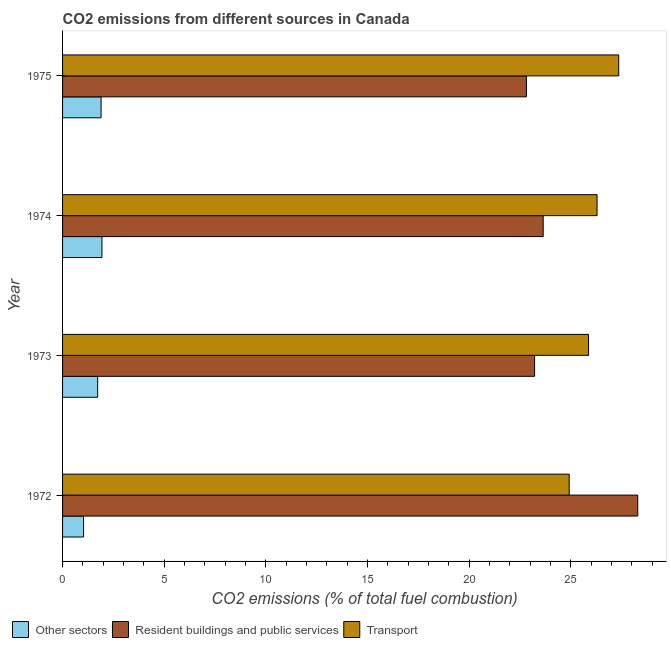How many different coloured bars are there?
Offer a very short reply. 3. Are the number of bars on each tick of the Y-axis equal?
Give a very brief answer. Yes. How many bars are there on the 3rd tick from the top?
Your response must be concise. 3. How many bars are there on the 1st tick from the bottom?
Keep it short and to the point. 3. In how many cases, is the number of bars for a given year not equal to the number of legend labels?
Offer a terse response. 0. What is the percentage of co2 emissions from transport in 1973?
Your answer should be very brief. 25.87. Across all years, what is the maximum percentage of co2 emissions from other sectors?
Your answer should be compact. 1.94. Across all years, what is the minimum percentage of co2 emissions from other sectors?
Give a very brief answer. 1.03. In which year was the percentage of co2 emissions from other sectors maximum?
Make the answer very short. 1974. In which year was the percentage of co2 emissions from resident buildings and public services minimum?
Provide a short and direct response. 1975. What is the total percentage of co2 emissions from transport in the graph?
Make the answer very short. 104.45. What is the difference between the percentage of co2 emissions from transport in 1973 and that in 1974?
Provide a short and direct response. -0.42. What is the difference between the percentage of co2 emissions from transport in 1974 and the percentage of co2 emissions from resident buildings and public services in 1972?
Offer a very short reply. -2. What is the average percentage of co2 emissions from other sectors per year?
Your answer should be compact. 1.65. In the year 1974, what is the difference between the percentage of co2 emissions from transport and percentage of co2 emissions from resident buildings and public services?
Make the answer very short. 2.65. In how many years, is the percentage of co2 emissions from other sectors greater than 20 %?
Keep it short and to the point. 0. What is the ratio of the percentage of co2 emissions from other sectors in 1972 to that in 1973?
Offer a very short reply. 0.6. Is the percentage of co2 emissions from resident buildings and public services in 1973 less than that in 1975?
Ensure brevity in your answer.  No. Is the difference between the percentage of co2 emissions from resident buildings and public services in 1973 and 1974 greater than the difference between the percentage of co2 emissions from other sectors in 1973 and 1974?
Make the answer very short. No. What is the difference between the highest and the second highest percentage of co2 emissions from other sectors?
Provide a succinct answer. 0.04. What is the difference between the highest and the lowest percentage of co2 emissions from transport?
Provide a short and direct response. 2.44. In how many years, is the percentage of co2 emissions from resident buildings and public services greater than the average percentage of co2 emissions from resident buildings and public services taken over all years?
Offer a terse response. 1. What does the 1st bar from the top in 1972 represents?
Your response must be concise. Transport. What does the 1st bar from the bottom in 1972 represents?
Provide a short and direct response. Other sectors. Is it the case that in every year, the sum of the percentage of co2 emissions from other sectors and percentage of co2 emissions from resident buildings and public services is greater than the percentage of co2 emissions from transport?
Your response must be concise. No. How many bars are there?
Your response must be concise. 12. Are all the bars in the graph horizontal?
Give a very brief answer. Yes. How many years are there in the graph?
Make the answer very short. 4. Does the graph contain any zero values?
Your response must be concise. No. Where does the legend appear in the graph?
Offer a terse response. Bottom left. How are the legend labels stacked?
Your response must be concise. Horizontal. What is the title of the graph?
Offer a terse response. CO2 emissions from different sources in Canada. What is the label or title of the X-axis?
Keep it short and to the point. CO2 emissions (% of total fuel combustion). What is the CO2 emissions (% of total fuel combustion) of Other sectors in 1972?
Provide a short and direct response. 1.03. What is the CO2 emissions (% of total fuel combustion) of Resident buildings and public services in 1972?
Your answer should be compact. 28.29. What is the CO2 emissions (% of total fuel combustion) in Transport in 1972?
Your response must be concise. 24.92. What is the CO2 emissions (% of total fuel combustion) in Other sectors in 1973?
Offer a terse response. 1.73. What is the CO2 emissions (% of total fuel combustion) in Resident buildings and public services in 1973?
Provide a short and direct response. 23.22. What is the CO2 emissions (% of total fuel combustion) of Transport in 1973?
Your answer should be compact. 25.87. What is the CO2 emissions (% of total fuel combustion) in Other sectors in 1974?
Make the answer very short. 1.94. What is the CO2 emissions (% of total fuel combustion) of Resident buildings and public services in 1974?
Your answer should be compact. 23.64. What is the CO2 emissions (% of total fuel combustion) in Transport in 1974?
Provide a succinct answer. 26.29. What is the CO2 emissions (% of total fuel combustion) of Other sectors in 1975?
Make the answer very short. 1.89. What is the CO2 emissions (% of total fuel combustion) in Resident buildings and public services in 1975?
Your answer should be compact. 22.82. What is the CO2 emissions (% of total fuel combustion) in Transport in 1975?
Provide a short and direct response. 27.36. Across all years, what is the maximum CO2 emissions (% of total fuel combustion) of Other sectors?
Your answer should be compact. 1.94. Across all years, what is the maximum CO2 emissions (% of total fuel combustion) of Resident buildings and public services?
Offer a very short reply. 28.29. Across all years, what is the maximum CO2 emissions (% of total fuel combustion) in Transport?
Provide a succinct answer. 27.36. Across all years, what is the minimum CO2 emissions (% of total fuel combustion) in Other sectors?
Your answer should be compact. 1.03. Across all years, what is the minimum CO2 emissions (% of total fuel combustion) of Resident buildings and public services?
Your answer should be compact. 22.82. Across all years, what is the minimum CO2 emissions (% of total fuel combustion) of Transport?
Offer a very short reply. 24.92. What is the total CO2 emissions (% of total fuel combustion) in Other sectors in the graph?
Provide a succinct answer. 6.59. What is the total CO2 emissions (% of total fuel combustion) in Resident buildings and public services in the graph?
Give a very brief answer. 97.97. What is the total CO2 emissions (% of total fuel combustion) in Transport in the graph?
Make the answer very short. 104.45. What is the difference between the CO2 emissions (% of total fuel combustion) of Other sectors in 1972 and that in 1973?
Offer a very short reply. -0.69. What is the difference between the CO2 emissions (% of total fuel combustion) of Resident buildings and public services in 1972 and that in 1973?
Give a very brief answer. 5.07. What is the difference between the CO2 emissions (% of total fuel combustion) in Transport in 1972 and that in 1973?
Give a very brief answer. -0.95. What is the difference between the CO2 emissions (% of total fuel combustion) of Other sectors in 1972 and that in 1974?
Your answer should be compact. -0.9. What is the difference between the CO2 emissions (% of total fuel combustion) in Resident buildings and public services in 1972 and that in 1974?
Give a very brief answer. 4.65. What is the difference between the CO2 emissions (% of total fuel combustion) in Transport in 1972 and that in 1974?
Offer a terse response. -1.37. What is the difference between the CO2 emissions (% of total fuel combustion) of Other sectors in 1972 and that in 1975?
Keep it short and to the point. -0.86. What is the difference between the CO2 emissions (% of total fuel combustion) of Resident buildings and public services in 1972 and that in 1975?
Give a very brief answer. 5.48. What is the difference between the CO2 emissions (% of total fuel combustion) in Transport in 1972 and that in 1975?
Ensure brevity in your answer.  -2.44. What is the difference between the CO2 emissions (% of total fuel combustion) in Other sectors in 1973 and that in 1974?
Your answer should be compact. -0.21. What is the difference between the CO2 emissions (% of total fuel combustion) of Resident buildings and public services in 1973 and that in 1974?
Offer a very short reply. -0.42. What is the difference between the CO2 emissions (% of total fuel combustion) in Transport in 1973 and that in 1974?
Ensure brevity in your answer.  -0.42. What is the difference between the CO2 emissions (% of total fuel combustion) of Other sectors in 1973 and that in 1975?
Give a very brief answer. -0.17. What is the difference between the CO2 emissions (% of total fuel combustion) of Resident buildings and public services in 1973 and that in 1975?
Ensure brevity in your answer.  0.4. What is the difference between the CO2 emissions (% of total fuel combustion) in Transport in 1973 and that in 1975?
Ensure brevity in your answer.  -1.48. What is the difference between the CO2 emissions (% of total fuel combustion) in Other sectors in 1974 and that in 1975?
Keep it short and to the point. 0.04. What is the difference between the CO2 emissions (% of total fuel combustion) in Resident buildings and public services in 1974 and that in 1975?
Ensure brevity in your answer.  0.82. What is the difference between the CO2 emissions (% of total fuel combustion) in Transport in 1974 and that in 1975?
Offer a terse response. -1.07. What is the difference between the CO2 emissions (% of total fuel combustion) in Other sectors in 1972 and the CO2 emissions (% of total fuel combustion) in Resident buildings and public services in 1973?
Make the answer very short. -22.19. What is the difference between the CO2 emissions (% of total fuel combustion) in Other sectors in 1972 and the CO2 emissions (% of total fuel combustion) in Transport in 1973?
Your answer should be very brief. -24.84. What is the difference between the CO2 emissions (% of total fuel combustion) in Resident buildings and public services in 1972 and the CO2 emissions (% of total fuel combustion) in Transport in 1973?
Your answer should be very brief. 2.42. What is the difference between the CO2 emissions (% of total fuel combustion) of Other sectors in 1972 and the CO2 emissions (% of total fuel combustion) of Resident buildings and public services in 1974?
Your response must be concise. -22.61. What is the difference between the CO2 emissions (% of total fuel combustion) of Other sectors in 1972 and the CO2 emissions (% of total fuel combustion) of Transport in 1974?
Make the answer very short. -25.26. What is the difference between the CO2 emissions (% of total fuel combustion) of Resident buildings and public services in 1972 and the CO2 emissions (% of total fuel combustion) of Transport in 1974?
Keep it short and to the point. 2. What is the difference between the CO2 emissions (% of total fuel combustion) of Other sectors in 1972 and the CO2 emissions (% of total fuel combustion) of Resident buildings and public services in 1975?
Ensure brevity in your answer.  -21.78. What is the difference between the CO2 emissions (% of total fuel combustion) of Other sectors in 1972 and the CO2 emissions (% of total fuel combustion) of Transport in 1975?
Your answer should be compact. -26.32. What is the difference between the CO2 emissions (% of total fuel combustion) of Resident buildings and public services in 1972 and the CO2 emissions (% of total fuel combustion) of Transport in 1975?
Your answer should be very brief. 0.94. What is the difference between the CO2 emissions (% of total fuel combustion) of Other sectors in 1973 and the CO2 emissions (% of total fuel combustion) of Resident buildings and public services in 1974?
Give a very brief answer. -21.92. What is the difference between the CO2 emissions (% of total fuel combustion) in Other sectors in 1973 and the CO2 emissions (% of total fuel combustion) in Transport in 1974?
Provide a succinct answer. -24.57. What is the difference between the CO2 emissions (% of total fuel combustion) in Resident buildings and public services in 1973 and the CO2 emissions (% of total fuel combustion) in Transport in 1974?
Make the answer very short. -3.07. What is the difference between the CO2 emissions (% of total fuel combustion) of Other sectors in 1973 and the CO2 emissions (% of total fuel combustion) of Resident buildings and public services in 1975?
Ensure brevity in your answer.  -21.09. What is the difference between the CO2 emissions (% of total fuel combustion) of Other sectors in 1973 and the CO2 emissions (% of total fuel combustion) of Transport in 1975?
Give a very brief answer. -25.63. What is the difference between the CO2 emissions (% of total fuel combustion) in Resident buildings and public services in 1973 and the CO2 emissions (% of total fuel combustion) in Transport in 1975?
Give a very brief answer. -4.14. What is the difference between the CO2 emissions (% of total fuel combustion) of Other sectors in 1974 and the CO2 emissions (% of total fuel combustion) of Resident buildings and public services in 1975?
Ensure brevity in your answer.  -20.88. What is the difference between the CO2 emissions (% of total fuel combustion) of Other sectors in 1974 and the CO2 emissions (% of total fuel combustion) of Transport in 1975?
Your answer should be compact. -25.42. What is the difference between the CO2 emissions (% of total fuel combustion) of Resident buildings and public services in 1974 and the CO2 emissions (% of total fuel combustion) of Transport in 1975?
Provide a succinct answer. -3.72. What is the average CO2 emissions (% of total fuel combustion) of Other sectors per year?
Keep it short and to the point. 1.65. What is the average CO2 emissions (% of total fuel combustion) of Resident buildings and public services per year?
Give a very brief answer. 24.49. What is the average CO2 emissions (% of total fuel combustion) of Transport per year?
Provide a succinct answer. 26.11. In the year 1972, what is the difference between the CO2 emissions (% of total fuel combustion) in Other sectors and CO2 emissions (% of total fuel combustion) in Resident buildings and public services?
Your answer should be compact. -27.26. In the year 1972, what is the difference between the CO2 emissions (% of total fuel combustion) in Other sectors and CO2 emissions (% of total fuel combustion) in Transport?
Your response must be concise. -23.89. In the year 1972, what is the difference between the CO2 emissions (% of total fuel combustion) of Resident buildings and public services and CO2 emissions (% of total fuel combustion) of Transport?
Your response must be concise. 3.37. In the year 1973, what is the difference between the CO2 emissions (% of total fuel combustion) in Other sectors and CO2 emissions (% of total fuel combustion) in Resident buildings and public services?
Provide a short and direct response. -21.49. In the year 1973, what is the difference between the CO2 emissions (% of total fuel combustion) in Other sectors and CO2 emissions (% of total fuel combustion) in Transport?
Your answer should be compact. -24.15. In the year 1973, what is the difference between the CO2 emissions (% of total fuel combustion) of Resident buildings and public services and CO2 emissions (% of total fuel combustion) of Transport?
Provide a short and direct response. -2.65. In the year 1974, what is the difference between the CO2 emissions (% of total fuel combustion) in Other sectors and CO2 emissions (% of total fuel combustion) in Resident buildings and public services?
Offer a terse response. -21.71. In the year 1974, what is the difference between the CO2 emissions (% of total fuel combustion) in Other sectors and CO2 emissions (% of total fuel combustion) in Transport?
Ensure brevity in your answer.  -24.36. In the year 1974, what is the difference between the CO2 emissions (% of total fuel combustion) of Resident buildings and public services and CO2 emissions (% of total fuel combustion) of Transport?
Your answer should be compact. -2.65. In the year 1975, what is the difference between the CO2 emissions (% of total fuel combustion) of Other sectors and CO2 emissions (% of total fuel combustion) of Resident buildings and public services?
Keep it short and to the point. -20.92. In the year 1975, what is the difference between the CO2 emissions (% of total fuel combustion) of Other sectors and CO2 emissions (% of total fuel combustion) of Transport?
Ensure brevity in your answer.  -25.46. In the year 1975, what is the difference between the CO2 emissions (% of total fuel combustion) in Resident buildings and public services and CO2 emissions (% of total fuel combustion) in Transport?
Your response must be concise. -4.54. What is the ratio of the CO2 emissions (% of total fuel combustion) in Other sectors in 1972 to that in 1973?
Offer a terse response. 0.6. What is the ratio of the CO2 emissions (% of total fuel combustion) in Resident buildings and public services in 1972 to that in 1973?
Provide a succinct answer. 1.22. What is the ratio of the CO2 emissions (% of total fuel combustion) in Transport in 1972 to that in 1973?
Ensure brevity in your answer.  0.96. What is the ratio of the CO2 emissions (% of total fuel combustion) in Other sectors in 1972 to that in 1974?
Provide a short and direct response. 0.53. What is the ratio of the CO2 emissions (% of total fuel combustion) of Resident buildings and public services in 1972 to that in 1974?
Your answer should be very brief. 1.2. What is the ratio of the CO2 emissions (% of total fuel combustion) of Transport in 1972 to that in 1974?
Your answer should be very brief. 0.95. What is the ratio of the CO2 emissions (% of total fuel combustion) of Other sectors in 1972 to that in 1975?
Ensure brevity in your answer.  0.55. What is the ratio of the CO2 emissions (% of total fuel combustion) in Resident buildings and public services in 1972 to that in 1975?
Provide a succinct answer. 1.24. What is the ratio of the CO2 emissions (% of total fuel combustion) of Transport in 1972 to that in 1975?
Your answer should be compact. 0.91. What is the ratio of the CO2 emissions (% of total fuel combustion) of Other sectors in 1973 to that in 1974?
Your answer should be compact. 0.89. What is the ratio of the CO2 emissions (% of total fuel combustion) of Resident buildings and public services in 1973 to that in 1974?
Ensure brevity in your answer.  0.98. What is the ratio of the CO2 emissions (% of total fuel combustion) in Transport in 1973 to that in 1974?
Your answer should be compact. 0.98. What is the ratio of the CO2 emissions (% of total fuel combustion) of Other sectors in 1973 to that in 1975?
Provide a short and direct response. 0.91. What is the ratio of the CO2 emissions (% of total fuel combustion) of Resident buildings and public services in 1973 to that in 1975?
Your answer should be very brief. 1.02. What is the ratio of the CO2 emissions (% of total fuel combustion) in Transport in 1973 to that in 1975?
Provide a short and direct response. 0.95. What is the ratio of the CO2 emissions (% of total fuel combustion) of Other sectors in 1974 to that in 1975?
Provide a short and direct response. 1.02. What is the ratio of the CO2 emissions (% of total fuel combustion) of Resident buildings and public services in 1974 to that in 1975?
Keep it short and to the point. 1.04. What is the difference between the highest and the second highest CO2 emissions (% of total fuel combustion) of Other sectors?
Keep it short and to the point. 0.04. What is the difference between the highest and the second highest CO2 emissions (% of total fuel combustion) in Resident buildings and public services?
Provide a succinct answer. 4.65. What is the difference between the highest and the second highest CO2 emissions (% of total fuel combustion) in Transport?
Provide a short and direct response. 1.07. What is the difference between the highest and the lowest CO2 emissions (% of total fuel combustion) of Other sectors?
Your answer should be compact. 0.9. What is the difference between the highest and the lowest CO2 emissions (% of total fuel combustion) in Resident buildings and public services?
Your response must be concise. 5.48. What is the difference between the highest and the lowest CO2 emissions (% of total fuel combustion) of Transport?
Offer a terse response. 2.44. 